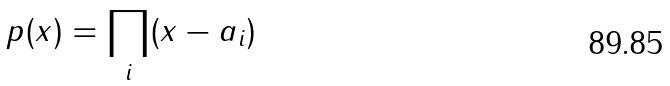Convert formula to latex. <formula><loc_0><loc_0><loc_500><loc_500>p ( x ) = \prod _ { i } ( x - a _ { i } )</formula> 